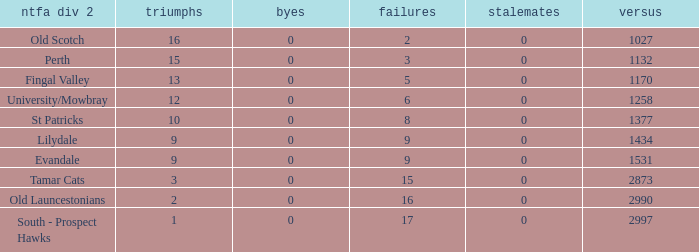What is the lowest number of draws of the NTFA Div 2 Lilydale? 0.0. 